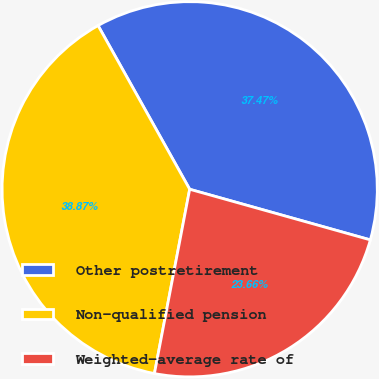Convert chart to OTSL. <chart><loc_0><loc_0><loc_500><loc_500><pie_chart><fcel>Other postretirement<fcel>Non-qualified pension<fcel>Weighted-average rate of<nl><fcel>37.47%<fcel>38.87%<fcel>23.66%<nl></chart> 